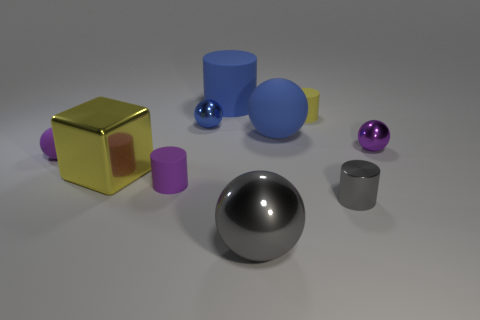What number of tiny cylinders are behind the large blue matte sphere?
Offer a terse response. 1. What number of tiny objects are behind the tiny purple rubber cylinder and right of the small blue metallic ball?
Offer a terse response. 2. There is a yellow thing that is made of the same material as the blue cylinder; what is its shape?
Your answer should be very brief. Cylinder. There is a sphere that is to the left of the small purple matte cylinder; is it the same size as the purple ball that is right of the large gray shiny object?
Ensure brevity in your answer.  Yes. What is the color of the matte cylinder in front of the cube?
Your answer should be very brief. Purple. What material is the yellow object that is in front of the thing to the right of the small gray cylinder?
Your answer should be very brief. Metal. The big yellow thing has what shape?
Your answer should be compact. Cube. There is a gray thing that is the same shape as the yellow matte object; what material is it?
Give a very brief answer. Metal. How many purple metallic balls are the same size as the purple matte cylinder?
Provide a succinct answer. 1. There is a tiny purple matte object in front of the metal block; is there a metallic cube that is behind it?
Give a very brief answer. Yes. 